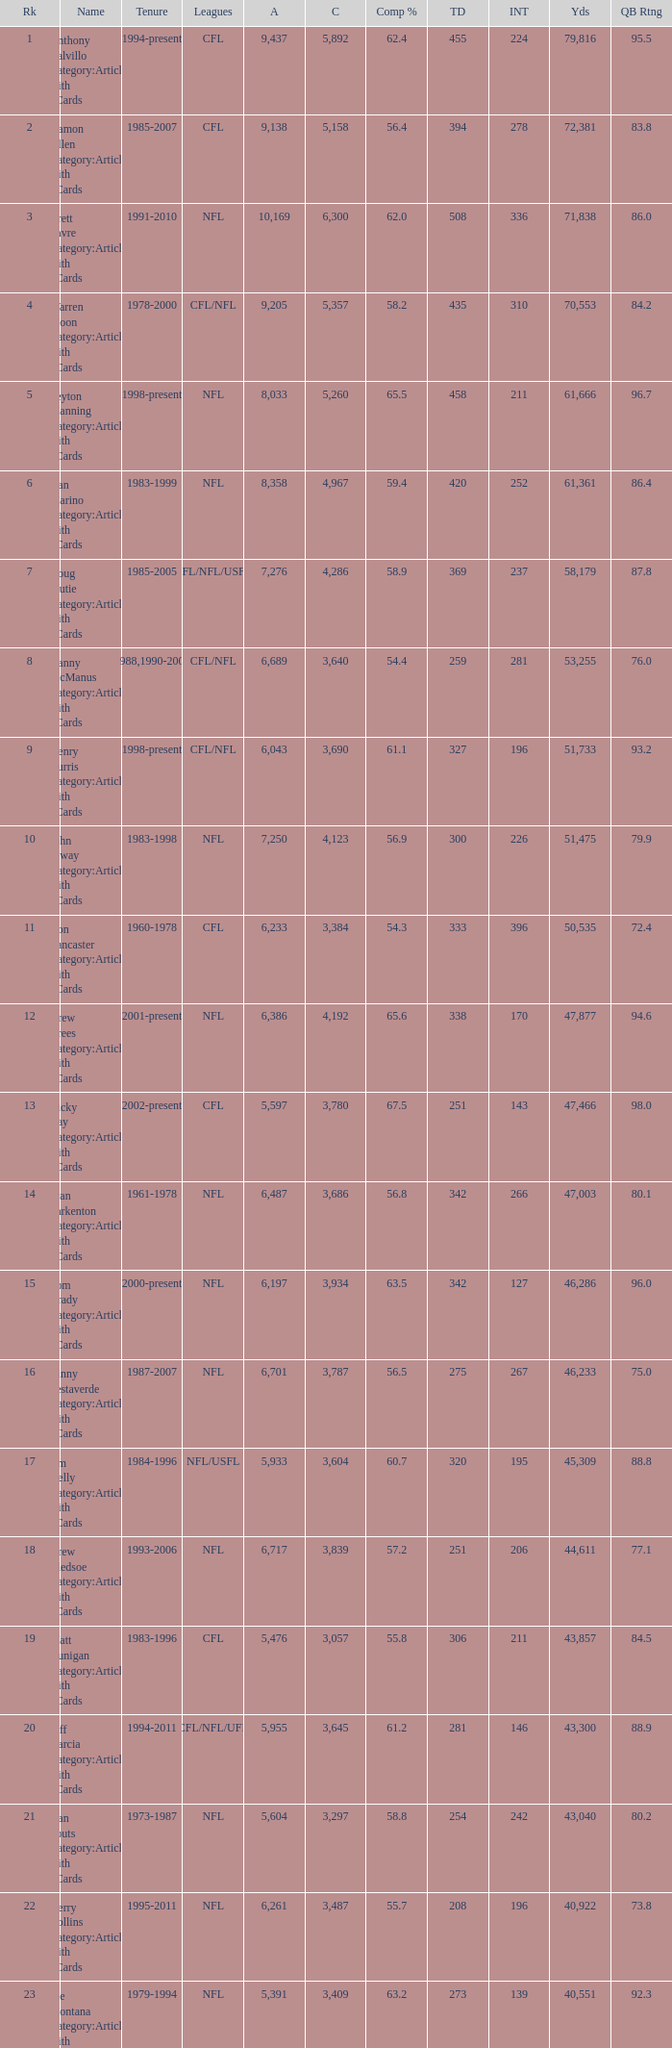What is the comp percentage when there are less than 44,611 in yardage, more than 254 touchdowns, and rank larger than 24? 54.6. 